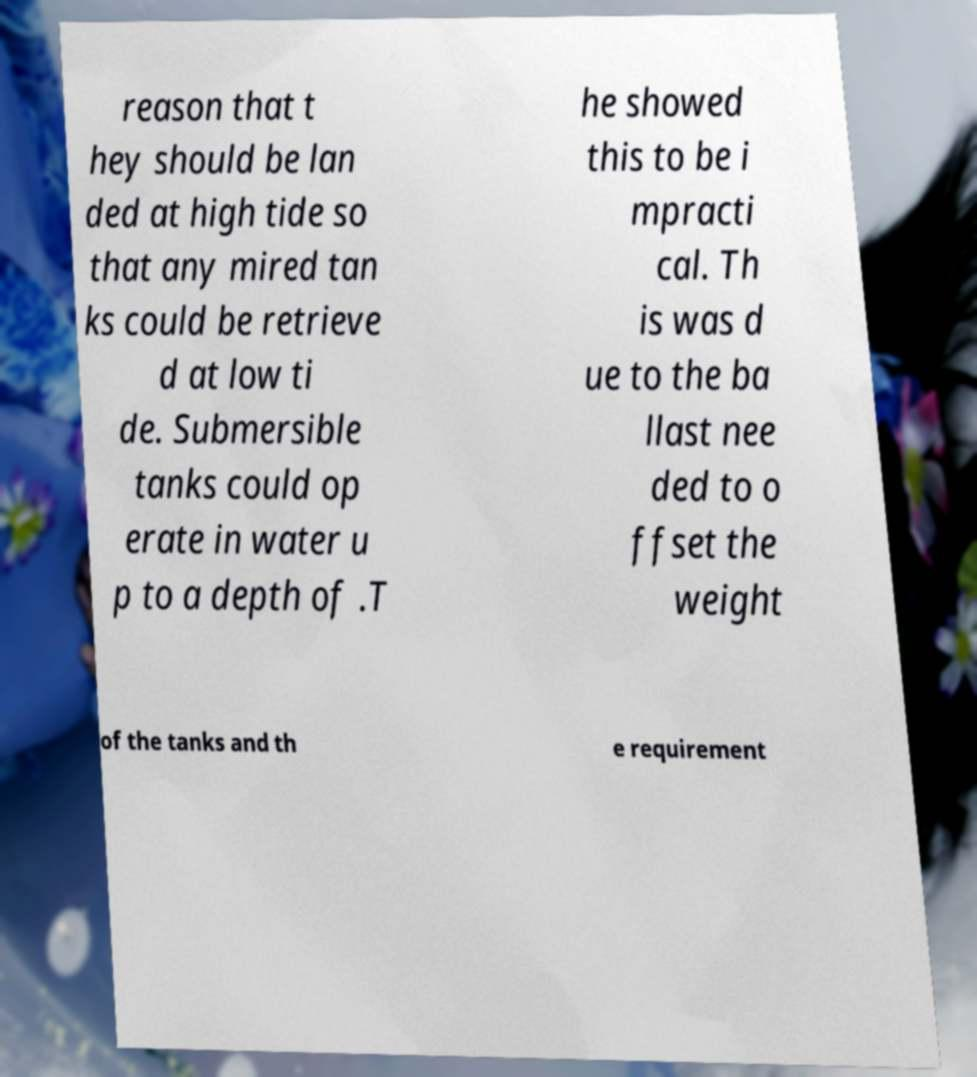For documentation purposes, I need the text within this image transcribed. Could you provide that? reason that t hey should be lan ded at high tide so that any mired tan ks could be retrieve d at low ti de. Submersible tanks could op erate in water u p to a depth of .T he showed this to be i mpracti cal. Th is was d ue to the ba llast nee ded to o ffset the weight of the tanks and th e requirement 